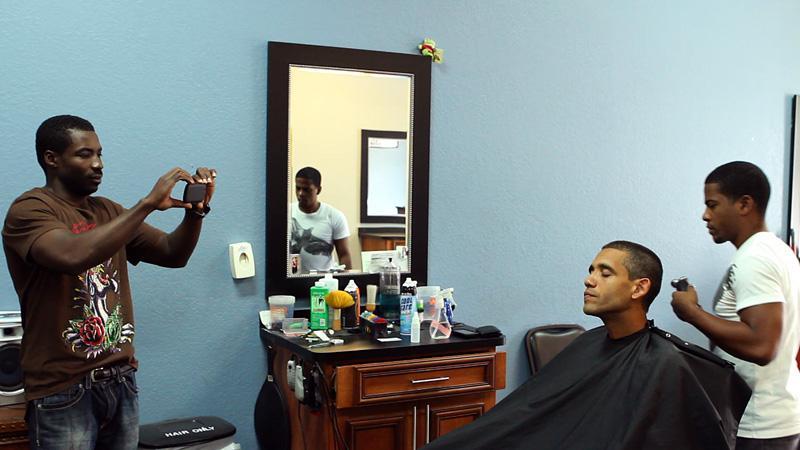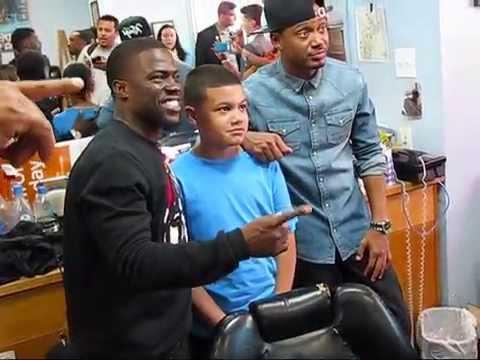The first image is the image on the left, the second image is the image on the right. Given the left and right images, does the statement "A barbershop scene includes at least two real non-smiling women." hold true? Answer yes or no. No. The first image is the image on the left, the second image is the image on the right. Considering the images on both sides, is "A barber is working on a former US president in one of the images" valid? Answer yes or no. Yes. 